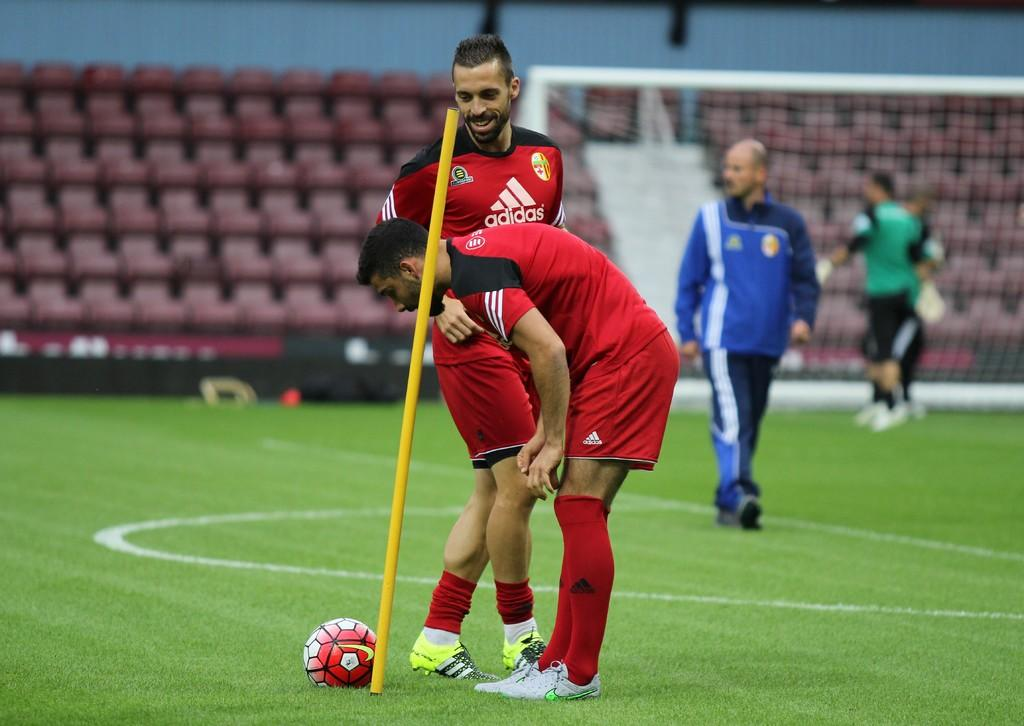<image>
Render a clear and concise summary of the photo. Two soccer players wearing jerseys sponsored by Adidas. 